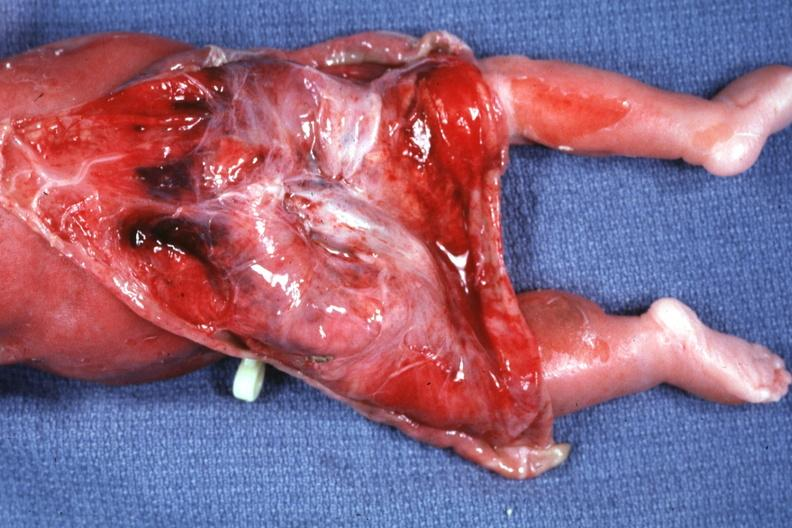s this section showing liver with tumor mass in hilar area tumor present?
Answer the question using a single word or phrase. No 